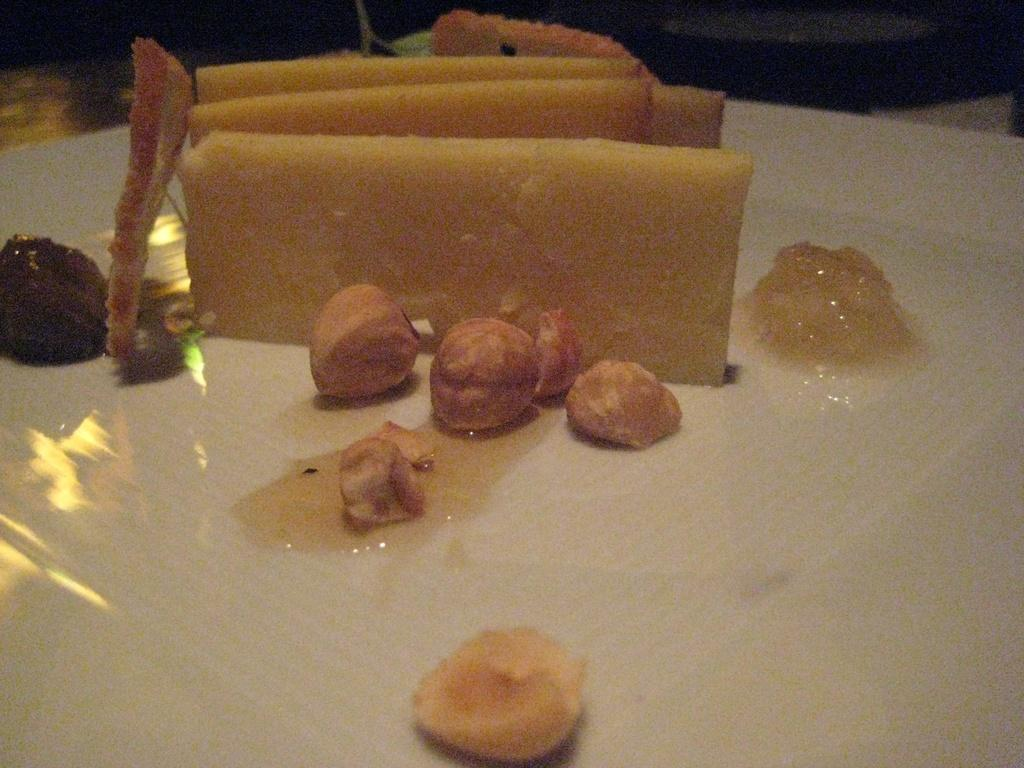What type of objects can be seen in the image? There are food items in the image. What is the color of the surface on which the food items are placed? The surface is white in color. What statement does the toe make in the image? There is no toe present in the image, so it cannot make any statement. 